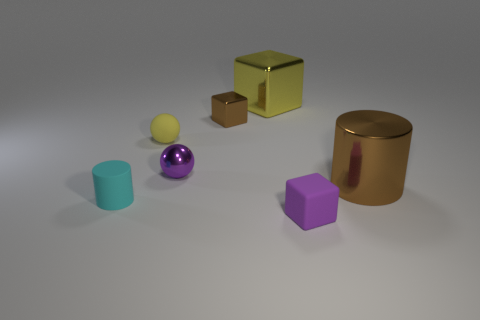Which object appears to be the largest in the image? The object that appears to be the largest in the image is the gold-colored cylinder on the right. 